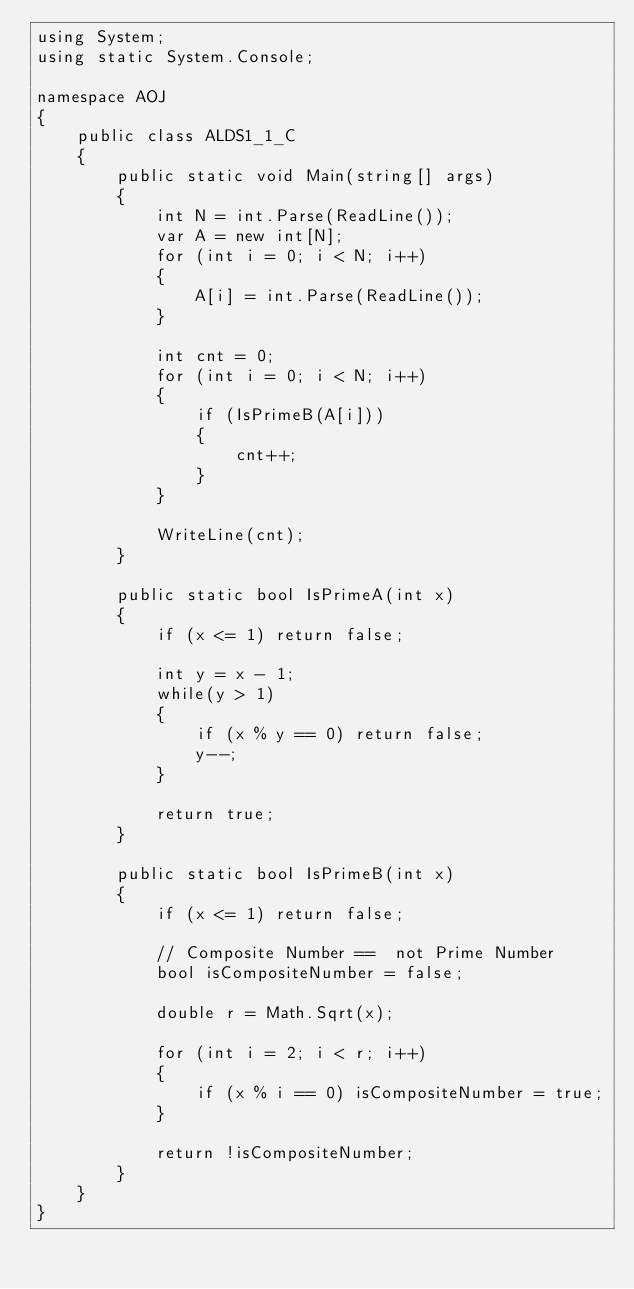<code> <loc_0><loc_0><loc_500><loc_500><_C#_>using System;
using static System.Console;

namespace AOJ
{
    public class ALDS1_1_C
    {
        public static void Main(string[] args)
        {
            int N = int.Parse(ReadLine());
            var A = new int[N];
            for (int i = 0; i < N; i++)
            {
                A[i] = int.Parse(ReadLine());
            }

            int cnt = 0;
            for (int i = 0; i < N; i++)
            {
                if (IsPrimeB(A[i]))
                {
                    cnt++;
                }
            }
            
            WriteLine(cnt);
        }

        public static bool IsPrimeA(int x)
        {
            if (x <= 1) return false;

            int y = x - 1;
            while(y > 1)
            {
                if (x % y == 0) return false;
                y--;
            }

            return true;
        }

        public static bool IsPrimeB(int x)
        {
            if (x <= 1) return false;
            
            // Composite Number ==  not Prime Number
            bool isCompositeNumber = false; 
            
            double r = Math.Sqrt(x);
            
            for (int i = 2; i < r; i++)
            {
                if (x % i == 0) isCompositeNumber = true;
            }

            return !isCompositeNumber;
        }
    }
}
</code> 